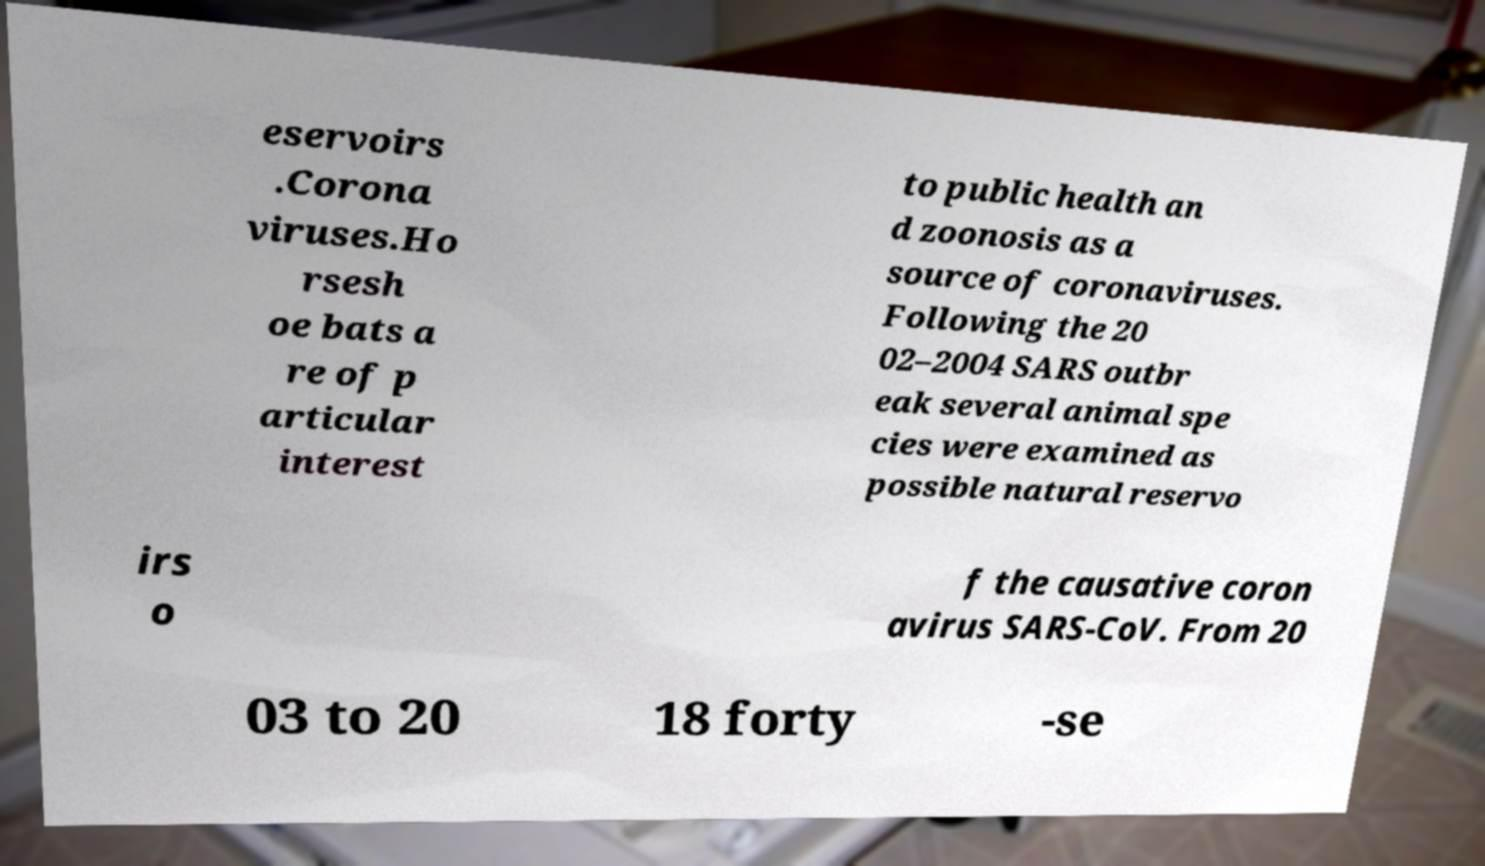Can you accurately transcribe the text from the provided image for me? eservoirs .Corona viruses.Ho rsesh oe bats a re of p articular interest to public health an d zoonosis as a source of coronaviruses. Following the 20 02–2004 SARS outbr eak several animal spe cies were examined as possible natural reservo irs o f the causative coron avirus SARS-CoV. From 20 03 to 20 18 forty -se 